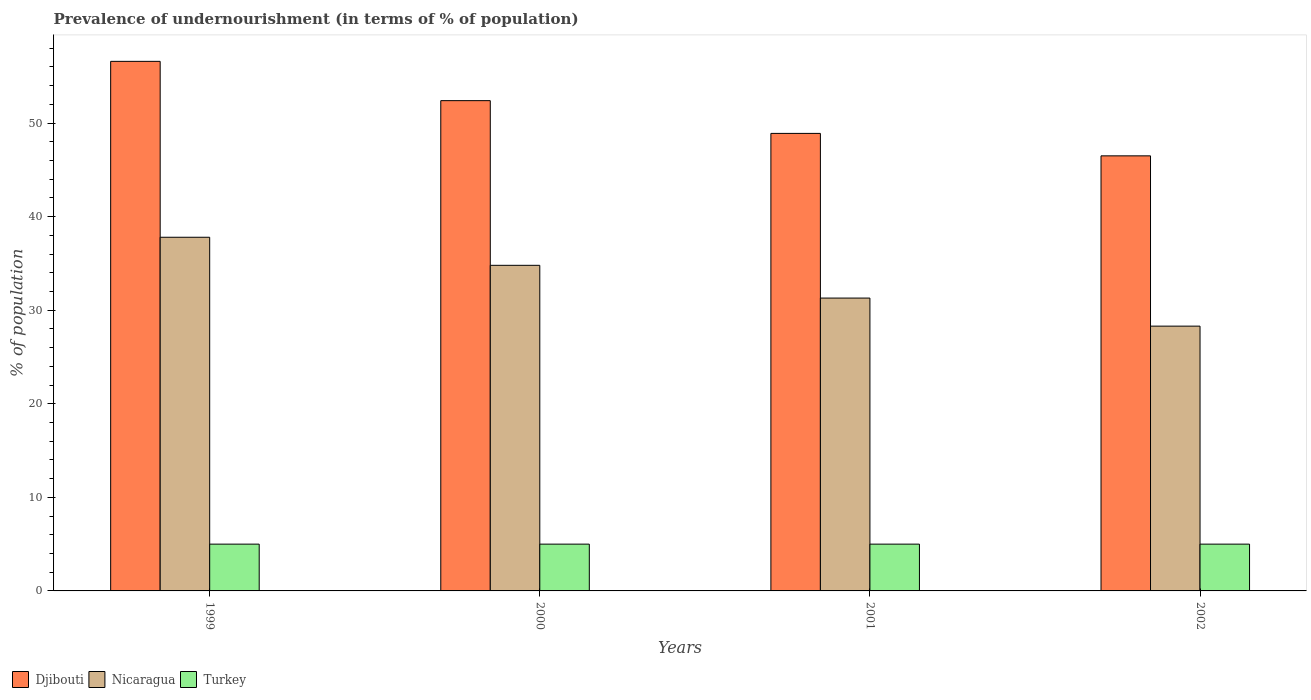How many different coloured bars are there?
Keep it short and to the point. 3. How many groups of bars are there?
Offer a very short reply. 4. Are the number of bars per tick equal to the number of legend labels?
Your answer should be very brief. Yes. How many bars are there on the 2nd tick from the left?
Offer a very short reply. 3. In how many cases, is the number of bars for a given year not equal to the number of legend labels?
Give a very brief answer. 0. What is the percentage of undernourished population in Djibouti in 2002?
Offer a very short reply. 46.5. Across all years, what is the maximum percentage of undernourished population in Djibouti?
Your answer should be compact. 56.6. Across all years, what is the minimum percentage of undernourished population in Turkey?
Offer a terse response. 5. In which year was the percentage of undernourished population in Djibouti maximum?
Your answer should be compact. 1999. In which year was the percentage of undernourished population in Nicaragua minimum?
Provide a short and direct response. 2002. What is the total percentage of undernourished population in Djibouti in the graph?
Keep it short and to the point. 204.4. What is the difference between the percentage of undernourished population in Djibouti in 1999 and that in 2002?
Ensure brevity in your answer.  10.1. What is the difference between the percentage of undernourished population in Djibouti in 2000 and the percentage of undernourished population in Nicaragua in 2002?
Your answer should be compact. 24.1. What is the average percentage of undernourished population in Nicaragua per year?
Your response must be concise. 33.05. In the year 2000, what is the difference between the percentage of undernourished population in Turkey and percentage of undernourished population in Nicaragua?
Ensure brevity in your answer.  -29.8. What is the ratio of the percentage of undernourished population in Nicaragua in 1999 to that in 2000?
Offer a very short reply. 1.09. Is the percentage of undernourished population in Nicaragua in 2000 less than that in 2001?
Keep it short and to the point. No. What is the difference between the highest and the second highest percentage of undernourished population in Djibouti?
Keep it short and to the point. 4.2. What is the difference between the highest and the lowest percentage of undernourished population in Nicaragua?
Provide a succinct answer. 9.5. In how many years, is the percentage of undernourished population in Turkey greater than the average percentage of undernourished population in Turkey taken over all years?
Keep it short and to the point. 0. What does the 1st bar from the left in 2000 represents?
Offer a terse response. Djibouti. Is it the case that in every year, the sum of the percentage of undernourished population in Nicaragua and percentage of undernourished population in Turkey is greater than the percentage of undernourished population in Djibouti?
Provide a succinct answer. No. How many bars are there?
Offer a terse response. 12. Are all the bars in the graph horizontal?
Your answer should be compact. No. What is the difference between two consecutive major ticks on the Y-axis?
Offer a very short reply. 10. Does the graph contain any zero values?
Offer a very short reply. No. Where does the legend appear in the graph?
Offer a very short reply. Bottom left. What is the title of the graph?
Your answer should be compact. Prevalence of undernourishment (in terms of % of population). Does "Sint Maarten (Dutch part)" appear as one of the legend labels in the graph?
Your response must be concise. No. What is the label or title of the Y-axis?
Provide a succinct answer. % of population. What is the % of population of Djibouti in 1999?
Keep it short and to the point. 56.6. What is the % of population of Nicaragua in 1999?
Your answer should be very brief. 37.8. What is the % of population in Djibouti in 2000?
Give a very brief answer. 52.4. What is the % of population in Nicaragua in 2000?
Make the answer very short. 34.8. What is the % of population in Djibouti in 2001?
Make the answer very short. 48.9. What is the % of population in Nicaragua in 2001?
Provide a succinct answer. 31.3. What is the % of population in Turkey in 2001?
Make the answer very short. 5. What is the % of population in Djibouti in 2002?
Offer a terse response. 46.5. What is the % of population of Nicaragua in 2002?
Ensure brevity in your answer.  28.3. What is the % of population in Turkey in 2002?
Your answer should be very brief. 5. Across all years, what is the maximum % of population in Djibouti?
Your response must be concise. 56.6. Across all years, what is the maximum % of population in Nicaragua?
Ensure brevity in your answer.  37.8. Across all years, what is the maximum % of population in Turkey?
Give a very brief answer. 5. Across all years, what is the minimum % of population in Djibouti?
Your answer should be compact. 46.5. Across all years, what is the minimum % of population of Nicaragua?
Your answer should be compact. 28.3. What is the total % of population in Djibouti in the graph?
Your answer should be very brief. 204.4. What is the total % of population of Nicaragua in the graph?
Provide a succinct answer. 132.2. What is the difference between the % of population in Djibouti in 1999 and that in 2000?
Your answer should be very brief. 4.2. What is the difference between the % of population of Turkey in 1999 and that in 2000?
Your answer should be very brief. 0. What is the difference between the % of population of Nicaragua in 1999 and that in 2001?
Your answer should be very brief. 6.5. What is the difference between the % of population in Turkey in 1999 and that in 2002?
Give a very brief answer. 0. What is the difference between the % of population in Turkey in 2000 and that in 2001?
Make the answer very short. 0. What is the difference between the % of population in Nicaragua in 2000 and that in 2002?
Provide a short and direct response. 6.5. What is the difference between the % of population of Turkey in 2000 and that in 2002?
Provide a short and direct response. 0. What is the difference between the % of population in Djibouti in 2001 and that in 2002?
Offer a terse response. 2.4. What is the difference between the % of population of Nicaragua in 2001 and that in 2002?
Ensure brevity in your answer.  3. What is the difference between the % of population in Djibouti in 1999 and the % of population in Nicaragua in 2000?
Ensure brevity in your answer.  21.8. What is the difference between the % of population in Djibouti in 1999 and the % of population in Turkey in 2000?
Offer a terse response. 51.6. What is the difference between the % of population of Nicaragua in 1999 and the % of population of Turkey in 2000?
Keep it short and to the point. 32.8. What is the difference between the % of population in Djibouti in 1999 and the % of population in Nicaragua in 2001?
Give a very brief answer. 25.3. What is the difference between the % of population of Djibouti in 1999 and the % of population of Turkey in 2001?
Your answer should be very brief. 51.6. What is the difference between the % of population of Nicaragua in 1999 and the % of population of Turkey in 2001?
Your answer should be compact. 32.8. What is the difference between the % of population of Djibouti in 1999 and the % of population of Nicaragua in 2002?
Make the answer very short. 28.3. What is the difference between the % of population of Djibouti in 1999 and the % of population of Turkey in 2002?
Your answer should be compact. 51.6. What is the difference between the % of population in Nicaragua in 1999 and the % of population in Turkey in 2002?
Offer a very short reply. 32.8. What is the difference between the % of population of Djibouti in 2000 and the % of population of Nicaragua in 2001?
Offer a very short reply. 21.1. What is the difference between the % of population in Djibouti in 2000 and the % of population in Turkey in 2001?
Your answer should be very brief. 47.4. What is the difference between the % of population in Nicaragua in 2000 and the % of population in Turkey in 2001?
Ensure brevity in your answer.  29.8. What is the difference between the % of population in Djibouti in 2000 and the % of population in Nicaragua in 2002?
Provide a short and direct response. 24.1. What is the difference between the % of population of Djibouti in 2000 and the % of population of Turkey in 2002?
Make the answer very short. 47.4. What is the difference between the % of population in Nicaragua in 2000 and the % of population in Turkey in 2002?
Your answer should be compact. 29.8. What is the difference between the % of population in Djibouti in 2001 and the % of population in Nicaragua in 2002?
Your answer should be compact. 20.6. What is the difference between the % of population in Djibouti in 2001 and the % of population in Turkey in 2002?
Your answer should be compact. 43.9. What is the difference between the % of population of Nicaragua in 2001 and the % of population of Turkey in 2002?
Your answer should be very brief. 26.3. What is the average % of population in Djibouti per year?
Provide a short and direct response. 51.1. What is the average % of population in Nicaragua per year?
Offer a terse response. 33.05. In the year 1999, what is the difference between the % of population in Djibouti and % of population in Turkey?
Your answer should be very brief. 51.6. In the year 1999, what is the difference between the % of population of Nicaragua and % of population of Turkey?
Give a very brief answer. 32.8. In the year 2000, what is the difference between the % of population in Djibouti and % of population in Turkey?
Ensure brevity in your answer.  47.4. In the year 2000, what is the difference between the % of population of Nicaragua and % of population of Turkey?
Offer a very short reply. 29.8. In the year 2001, what is the difference between the % of population of Djibouti and % of population of Nicaragua?
Your response must be concise. 17.6. In the year 2001, what is the difference between the % of population in Djibouti and % of population in Turkey?
Your answer should be compact. 43.9. In the year 2001, what is the difference between the % of population of Nicaragua and % of population of Turkey?
Offer a terse response. 26.3. In the year 2002, what is the difference between the % of population in Djibouti and % of population in Nicaragua?
Keep it short and to the point. 18.2. In the year 2002, what is the difference between the % of population of Djibouti and % of population of Turkey?
Your answer should be compact. 41.5. In the year 2002, what is the difference between the % of population of Nicaragua and % of population of Turkey?
Provide a succinct answer. 23.3. What is the ratio of the % of population in Djibouti in 1999 to that in 2000?
Ensure brevity in your answer.  1.08. What is the ratio of the % of population in Nicaragua in 1999 to that in 2000?
Keep it short and to the point. 1.09. What is the ratio of the % of population in Djibouti in 1999 to that in 2001?
Your answer should be very brief. 1.16. What is the ratio of the % of population of Nicaragua in 1999 to that in 2001?
Offer a very short reply. 1.21. What is the ratio of the % of population in Djibouti in 1999 to that in 2002?
Your answer should be compact. 1.22. What is the ratio of the % of population in Nicaragua in 1999 to that in 2002?
Give a very brief answer. 1.34. What is the ratio of the % of population of Turkey in 1999 to that in 2002?
Provide a succinct answer. 1. What is the ratio of the % of population of Djibouti in 2000 to that in 2001?
Offer a terse response. 1.07. What is the ratio of the % of population of Nicaragua in 2000 to that in 2001?
Your answer should be compact. 1.11. What is the ratio of the % of population in Turkey in 2000 to that in 2001?
Keep it short and to the point. 1. What is the ratio of the % of population of Djibouti in 2000 to that in 2002?
Offer a very short reply. 1.13. What is the ratio of the % of population in Nicaragua in 2000 to that in 2002?
Give a very brief answer. 1.23. What is the ratio of the % of population in Turkey in 2000 to that in 2002?
Your response must be concise. 1. What is the ratio of the % of population in Djibouti in 2001 to that in 2002?
Offer a terse response. 1.05. What is the ratio of the % of population in Nicaragua in 2001 to that in 2002?
Offer a terse response. 1.11. What is the ratio of the % of population in Turkey in 2001 to that in 2002?
Provide a succinct answer. 1. What is the difference between the highest and the second highest % of population in Nicaragua?
Offer a terse response. 3. What is the difference between the highest and the second highest % of population of Turkey?
Keep it short and to the point. 0. What is the difference between the highest and the lowest % of population in Djibouti?
Your answer should be very brief. 10.1. What is the difference between the highest and the lowest % of population in Nicaragua?
Make the answer very short. 9.5. What is the difference between the highest and the lowest % of population in Turkey?
Provide a succinct answer. 0. 